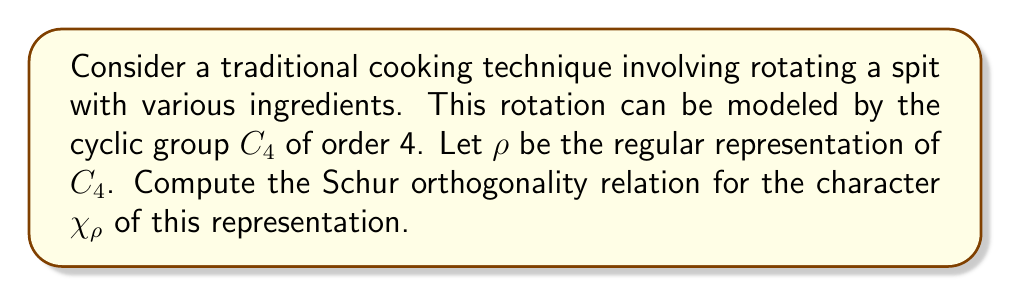Can you solve this math problem? 1) The regular representation $\rho$ of $C_4$ is 4-dimensional, with character values:
   $\chi_\rho(e) = 4$, $\chi_\rho(r) = \chi_\rho(r^2) = \chi_\rho(r^3) = 0$
   where $e$ is the identity and $r$ is the generator of $C_4$.

2) The Schur orthogonality relation for characters states:
   $$\frac{1}{|G|} \sum_{g \in G} \chi(g)\overline{\chi(g)} = 1$$
   where $|G|$ is the order of the group.

3) For $C_4$, $|G| = 4$. Let's compute the sum:
   $$\frac{1}{4}(\chi_\rho(e)\overline{\chi_\rho(e)} + \chi_\rho(r)\overline{\chi_\rho(r)} + \chi_\rho(r^2)\overline{\chi_\rho(r^2)} + \chi_\rho(r^3)\overline{\chi_\rho(r^3)})$$

4) Substituting the character values:
   $$\frac{1}{4}(4 \cdot 4 + 0 \cdot 0 + 0 \cdot 0 + 0 \cdot 0) = \frac{1}{4}(16) = 4$$

5) The result is 4, which equals the dimension of the representation. This is expected for the regular representation of any finite group.
Answer: 4 